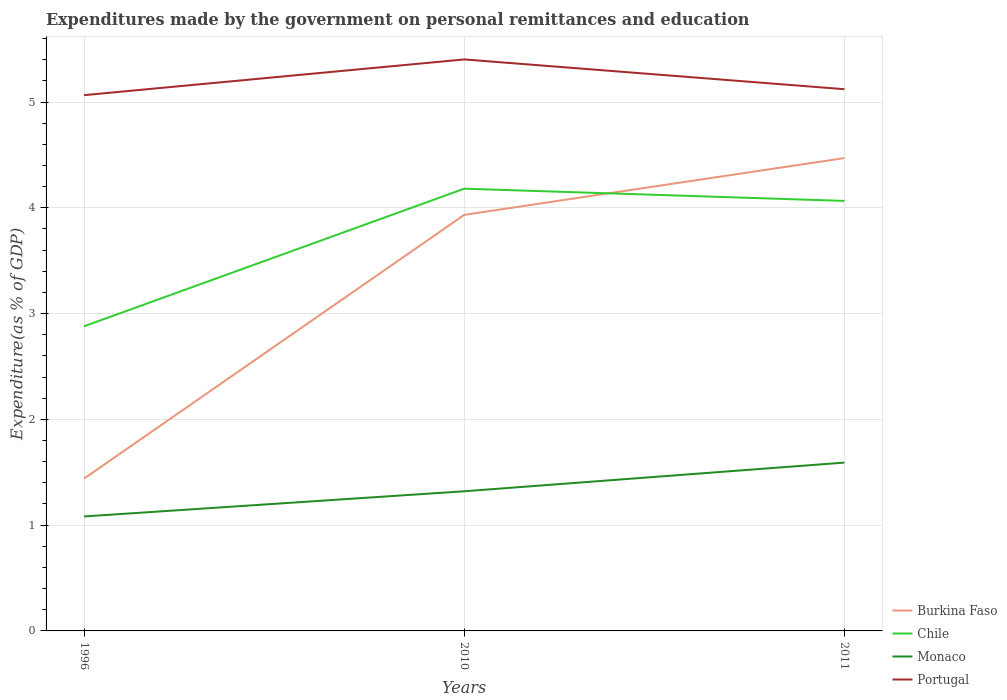How many different coloured lines are there?
Your answer should be compact. 4. Is the number of lines equal to the number of legend labels?
Provide a succinct answer. Yes. Across all years, what is the maximum expenditures made by the government on personal remittances and education in Portugal?
Provide a short and direct response. 5.07. In which year was the expenditures made by the government on personal remittances and education in Portugal maximum?
Your answer should be compact. 1996. What is the total expenditures made by the government on personal remittances and education in Burkina Faso in the graph?
Your answer should be very brief. -3.03. What is the difference between the highest and the second highest expenditures made by the government on personal remittances and education in Burkina Faso?
Provide a short and direct response. 3.03. Are the values on the major ticks of Y-axis written in scientific E-notation?
Give a very brief answer. No. Does the graph contain any zero values?
Provide a short and direct response. No. Where does the legend appear in the graph?
Make the answer very short. Bottom right. How many legend labels are there?
Offer a terse response. 4. How are the legend labels stacked?
Keep it short and to the point. Vertical. What is the title of the graph?
Offer a terse response. Expenditures made by the government on personal remittances and education. What is the label or title of the X-axis?
Provide a succinct answer. Years. What is the label or title of the Y-axis?
Keep it short and to the point. Expenditure(as % of GDP). What is the Expenditure(as % of GDP) of Burkina Faso in 1996?
Your answer should be very brief. 1.44. What is the Expenditure(as % of GDP) in Chile in 1996?
Ensure brevity in your answer.  2.88. What is the Expenditure(as % of GDP) in Monaco in 1996?
Your response must be concise. 1.08. What is the Expenditure(as % of GDP) of Portugal in 1996?
Keep it short and to the point. 5.07. What is the Expenditure(as % of GDP) of Burkina Faso in 2010?
Give a very brief answer. 3.93. What is the Expenditure(as % of GDP) in Chile in 2010?
Offer a very short reply. 4.18. What is the Expenditure(as % of GDP) of Monaco in 2010?
Provide a short and direct response. 1.32. What is the Expenditure(as % of GDP) in Portugal in 2010?
Your answer should be compact. 5.4. What is the Expenditure(as % of GDP) in Burkina Faso in 2011?
Give a very brief answer. 4.47. What is the Expenditure(as % of GDP) in Chile in 2011?
Your response must be concise. 4.07. What is the Expenditure(as % of GDP) of Monaco in 2011?
Keep it short and to the point. 1.59. What is the Expenditure(as % of GDP) of Portugal in 2011?
Your answer should be compact. 5.12. Across all years, what is the maximum Expenditure(as % of GDP) in Burkina Faso?
Keep it short and to the point. 4.47. Across all years, what is the maximum Expenditure(as % of GDP) of Chile?
Give a very brief answer. 4.18. Across all years, what is the maximum Expenditure(as % of GDP) of Monaco?
Offer a very short reply. 1.59. Across all years, what is the maximum Expenditure(as % of GDP) in Portugal?
Offer a terse response. 5.4. Across all years, what is the minimum Expenditure(as % of GDP) of Burkina Faso?
Keep it short and to the point. 1.44. Across all years, what is the minimum Expenditure(as % of GDP) in Chile?
Provide a succinct answer. 2.88. Across all years, what is the minimum Expenditure(as % of GDP) of Monaco?
Your answer should be very brief. 1.08. Across all years, what is the minimum Expenditure(as % of GDP) of Portugal?
Make the answer very short. 5.07. What is the total Expenditure(as % of GDP) of Burkina Faso in the graph?
Provide a short and direct response. 9.84. What is the total Expenditure(as % of GDP) of Chile in the graph?
Your answer should be compact. 11.13. What is the total Expenditure(as % of GDP) of Monaco in the graph?
Offer a very short reply. 3.99. What is the total Expenditure(as % of GDP) in Portugal in the graph?
Ensure brevity in your answer.  15.59. What is the difference between the Expenditure(as % of GDP) in Burkina Faso in 1996 and that in 2010?
Make the answer very short. -2.49. What is the difference between the Expenditure(as % of GDP) of Chile in 1996 and that in 2010?
Keep it short and to the point. -1.3. What is the difference between the Expenditure(as % of GDP) of Monaco in 1996 and that in 2010?
Offer a terse response. -0.24. What is the difference between the Expenditure(as % of GDP) in Portugal in 1996 and that in 2010?
Keep it short and to the point. -0.34. What is the difference between the Expenditure(as % of GDP) in Burkina Faso in 1996 and that in 2011?
Provide a short and direct response. -3.03. What is the difference between the Expenditure(as % of GDP) of Chile in 1996 and that in 2011?
Your answer should be compact. -1.19. What is the difference between the Expenditure(as % of GDP) of Monaco in 1996 and that in 2011?
Provide a short and direct response. -0.51. What is the difference between the Expenditure(as % of GDP) of Portugal in 1996 and that in 2011?
Keep it short and to the point. -0.06. What is the difference between the Expenditure(as % of GDP) of Burkina Faso in 2010 and that in 2011?
Give a very brief answer. -0.54. What is the difference between the Expenditure(as % of GDP) in Chile in 2010 and that in 2011?
Offer a terse response. 0.12. What is the difference between the Expenditure(as % of GDP) of Monaco in 2010 and that in 2011?
Ensure brevity in your answer.  -0.27. What is the difference between the Expenditure(as % of GDP) of Portugal in 2010 and that in 2011?
Provide a succinct answer. 0.28. What is the difference between the Expenditure(as % of GDP) of Burkina Faso in 1996 and the Expenditure(as % of GDP) of Chile in 2010?
Provide a short and direct response. -2.74. What is the difference between the Expenditure(as % of GDP) of Burkina Faso in 1996 and the Expenditure(as % of GDP) of Monaco in 2010?
Ensure brevity in your answer.  0.12. What is the difference between the Expenditure(as % of GDP) in Burkina Faso in 1996 and the Expenditure(as % of GDP) in Portugal in 2010?
Your answer should be very brief. -3.96. What is the difference between the Expenditure(as % of GDP) in Chile in 1996 and the Expenditure(as % of GDP) in Monaco in 2010?
Your answer should be compact. 1.56. What is the difference between the Expenditure(as % of GDP) in Chile in 1996 and the Expenditure(as % of GDP) in Portugal in 2010?
Provide a short and direct response. -2.52. What is the difference between the Expenditure(as % of GDP) in Monaco in 1996 and the Expenditure(as % of GDP) in Portugal in 2010?
Ensure brevity in your answer.  -4.32. What is the difference between the Expenditure(as % of GDP) of Burkina Faso in 1996 and the Expenditure(as % of GDP) of Chile in 2011?
Your answer should be very brief. -2.62. What is the difference between the Expenditure(as % of GDP) in Burkina Faso in 1996 and the Expenditure(as % of GDP) in Monaco in 2011?
Keep it short and to the point. -0.15. What is the difference between the Expenditure(as % of GDP) of Burkina Faso in 1996 and the Expenditure(as % of GDP) of Portugal in 2011?
Make the answer very short. -3.68. What is the difference between the Expenditure(as % of GDP) of Chile in 1996 and the Expenditure(as % of GDP) of Monaco in 2011?
Ensure brevity in your answer.  1.29. What is the difference between the Expenditure(as % of GDP) of Chile in 1996 and the Expenditure(as % of GDP) of Portugal in 2011?
Provide a succinct answer. -2.24. What is the difference between the Expenditure(as % of GDP) of Monaco in 1996 and the Expenditure(as % of GDP) of Portugal in 2011?
Offer a terse response. -4.04. What is the difference between the Expenditure(as % of GDP) of Burkina Faso in 2010 and the Expenditure(as % of GDP) of Chile in 2011?
Your answer should be very brief. -0.13. What is the difference between the Expenditure(as % of GDP) of Burkina Faso in 2010 and the Expenditure(as % of GDP) of Monaco in 2011?
Ensure brevity in your answer.  2.34. What is the difference between the Expenditure(as % of GDP) of Burkina Faso in 2010 and the Expenditure(as % of GDP) of Portugal in 2011?
Your response must be concise. -1.19. What is the difference between the Expenditure(as % of GDP) in Chile in 2010 and the Expenditure(as % of GDP) in Monaco in 2011?
Make the answer very short. 2.59. What is the difference between the Expenditure(as % of GDP) in Chile in 2010 and the Expenditure(as % of GDP) in Portugal in 2011?
Provide a succinct answer. -0.94. What is the difference between the Expenditure(as % of GDP) of Monaco in 2010 and the Expenditure(as % of GDP) of Portugal in 2011?
Make the answer very short. -3.8. What is the average Expenditure(as % of GDP) in Burkina Faso per year?
Your answer should be compact. 3.28. What is the average Expenditure(as % of GDP) of Chile per year?
Keep it short and to the point. 3.71. What is the average Expenditure(as % of GDP) in Monaco per year?
Your response must be concise. 1.33. What is the average Expenditure(as % of GDP) of Portugal per year?
Offer a very short reply. 5.2. In the year 1996, what is the difference between the Expenditure(as % of GDP) of Burkina Faso and Expenditure(as % of GDP) of Chile?
Provide a succinct answer. -1.44. In the year 1996, what is the difference between the Expenditure(as % of GDP) in Burkina Faso and Expenditure(as % of GDP) in Monaco?
Your answer should be compact. 0.36. In the year 1996, what is the difference between the Expenditure(as % of GDP) in Burkina Faso and Expenditure(as % of GDP) in Portugal?
Provide a short and direct response. -3.62. In the year 1996, what is the difference between the Expenditure(as % of GDP) in Chile and Expenditure(as % of GDP) in Monaco?
Keep it short and to the point. 1.8. In the year 1996, what is the difference between the Expenditure(as % of GDP) of Chile and Expenditure(as % of GDP) of Portugal?
Ensure brevity in your answer.  -2.19. In the year 1996, what is the difference between the Expenditure(as % of GDP) in Monaco and Expenditure(as % of GDP) in Portugal?
Your answer should be compact. -3.98. In the year 2010, what is the difference between the Expenditure(as % of GDP) of Burkina Faso and Expenditure(as % of GDP) of Chile?
Ensure brevity in your answer.  -0.25. In the year 2010, what is the difference between the Expenditure(as % of GDP) in Burkina Faso and Expenditure(as % of GDP) in Monaco?
Your answer should be compact. 2.61. In the year 2010, what is the difference between the Expenditure(as % of GDP) of Burkina Faso and Expenditure(as % of GDP) of Portugal?
Offer a terse response. -1.47. In the year 2010, what is the difference between the Expenditure(as % of GDP) of Chile and Expenditure(as % of GDP) of Monaco?
Your answer should be compact. 2.86. In the year 2010, what is the difference between the Expenditure(as % of GDP) in Chile and Expenditure(as % of GDP) in Portugal?
Make the answer very short. -1.22. In the year 2010, what is the difference between the Expenditure(as % of GDP) in Monaco and Expenditure(as % of GDP) in Portugal?
Give a very brief answer. -4.08. In the year 2011, what is the difference between the Expenditure(as % of GDP) of Burkina Faso and Expenditure(as % of GDP) of Chile?
Your answer should be compact. 0.4. In the year 2011, what is the difference between the Expenditure(as % of GDP) in Burkina Faso and Expenditure(as % of GDP) in Monaco?
Your response must be concise. 2.88. In the year 2011, what is the difference between the Expenditure(as % of GDP) of Burkina Faso and Expenditure(as % of GDP) of Portugal?
Provide a short and direct response. -0.65. In the year 2011, what is the difference between the Expenditure(as % of GDP) in Chile and Expenditure(as % of GDP) in Monaco?
Offer a terse response. 2.47. In the year 2011, what is the difference between the Expenditure(as % of GDP) of Chile and Expenditure(as % of GDP) of Portugal?
Offer a terse response. -1.06. In the year 2011, what is the difference between the Expenditure(as % of GDP) in Monaco and Expenditure(as % of GDP) in Portugal?
Provide a succinct answer. -3.53. What is the ratio of the Expenditure(as % of GDP) of Burkina Faso in 1996 to that in 2010?
Your response must be concise. 0.37. What is the ratio of the Expenditure(as % of GDP) in Chile in 1996 to that in 2010?
Your response must be concise. 0.69. What is the ratio of the Expenditure(as % of GDP) in Monaco in 1996 to that in 2010?
Your answer should be very brief. 0.82. What is the ratio of the Expenditure(as % of GDP) in Burkina Faso in 1996 to that in 2011?
Give a very brief answer. 0.32. What is the ratio of the Expenditure(as % of GDP) in Chile in 1996 to that in 2011?
Your answer should be compact. 0.71. What is the ratio of the Expenditure(as % of GDP) of Monaco in 1996 to that in 2011?
Your answer should be compact. 0.68. What is the ratio of the Expenditure(as % of GDP) of Burkina Faso in 2010 to that in 2011?
Your answer should be very brief. 0.88. What is the ratio of the Expenditure(as % of GDP) in Chile in 2010 to that in 2011?
Provide a short and direct response. 1.03. What is the ratio of the Expenditure(as % of GDP) in Monaco in 2010 to that in 2011?
Provide a succinct answer. 0.83. What is the ratio of the Expenditure(as % of GDP) of Portugal in 2010 to that in 2011?
Make the answer very short. 1.05. What is the difference between the highest and the second highest Expenditure(as % of GDP) in Burkina Faso?
Offer a terse response. 0.54. What is the difference between the highest and the second highest Expenditure(as % of GDP) in Chile?
Provide a succinct answer. 0.12. What is the difference between the highest and the second highest Expenditure(as % of GDP) of Monaco?
Your answer should be very brief. 0.27. What is the difference between the highest and the second highest Expenditure(as % of GDP) in Portugal?
Offer a terse response. 0.28. What is the difference between the highest and the lowest Expenditure(as % of GDP) in Burkina Faso?
Your response must be concise. 3.03. What is the difference between the highest and the lowest Expenditure(as % of GDP) in Chile?
Make the answer very short. 1.3. What is the difference between the highest and the lowest Expenditure(as % of GDP) of Monaco?
Your response must be concise. 0.51. What is the difference between the highest and the lowest Expenditure(as % of GDP) in Portugal?
Give a very brief answer. 0.34. 